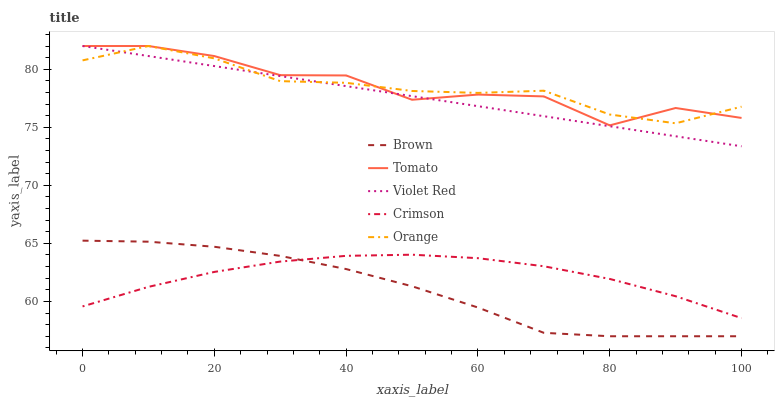Does Brown have the minimum area under the curve?
Answer yes or no. Yes. Does Tomato have the maximum area under the curve?
Answer yes or no. Yes. Does Violet Red have the minimum area under the curve?
Answer yes or no. No. Does Violet Red have the maximum area under the curve?
Answer yes or no. No. Is Violet Red the smoothest?
Answer yes or no. Yes. Is Tomato the roughest?
Answer yes or no. Yes. Is Brown the smoothest?
Answer yes or no. No. Is Brown the roughest?
Answer yes or no. No. Does Violet Red have the lowest value?
Answer yes or no. No. Does Brown have the highest value?
Answer yes or no. No. Is Brown less than Orange?
Answer yes or no. Yes. Is Violet Red greater than Crimson?
Answer yes or no. Yes. Does Brown intersect Orange?
Answer yes or no. No. 